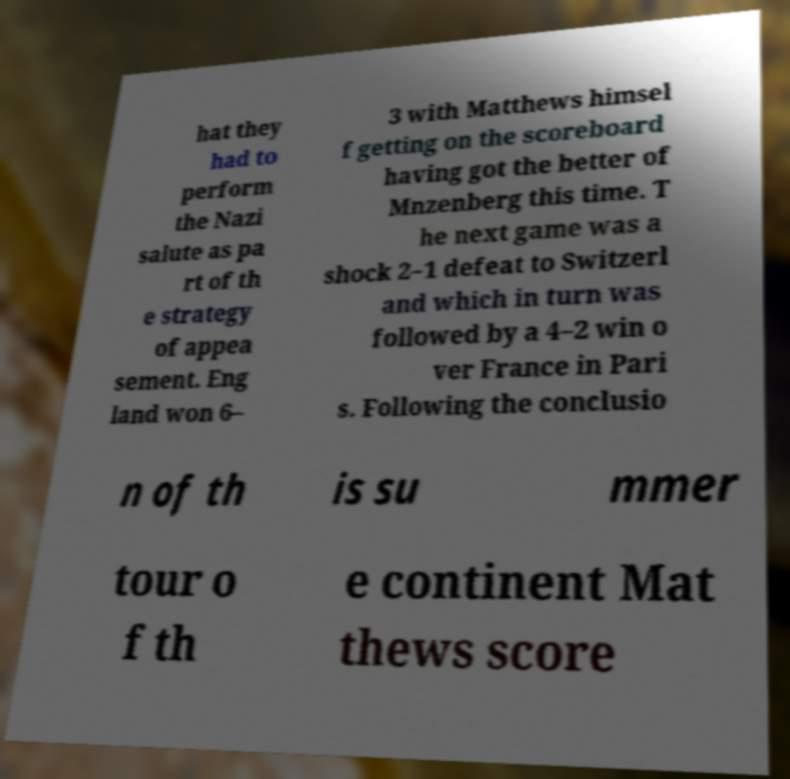Please read and relay the text visible in this image. What does it say? hat they had to perform the Nazi salute as pa rt of th e strategy of appea sement. Eng land won 6– 3 with Matthews himsel f getting on the scoreboard having got the better of Mnzenberg this time. T he next game was a shock 2–1 defeat to Switzerl and which in turn was followed by a 4–2 win o ver France in Pari s. Following the conclusio n of th is su mmer tour o f th e continent Mat thews score 